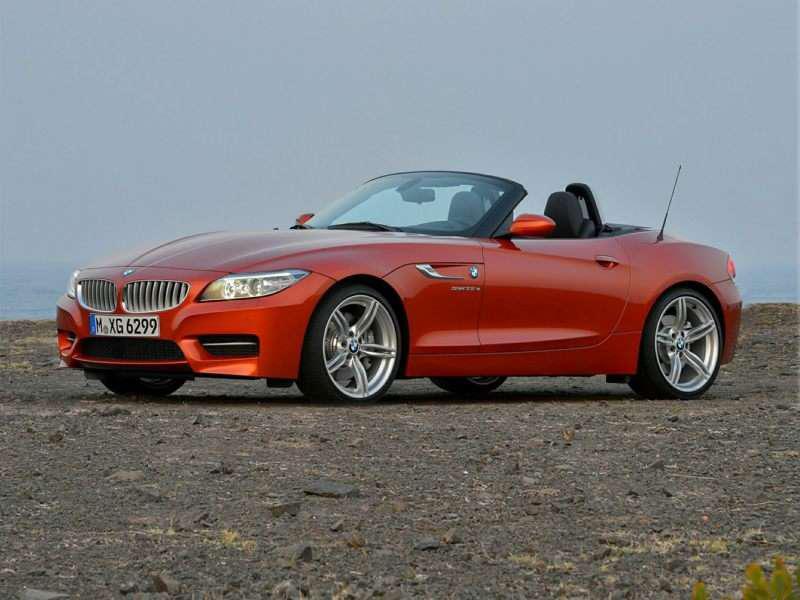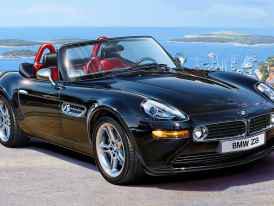The first image is the image on the left, the second image is the image on the right. For the images displayed, is the sentence "A body of water is in the background of a convertible in one of the images." factually correct? Answer yes or no. Yes. The first image is the image on the left, the second image is the image on the right. Evaluate the accuracy of this statement regarding the images: "One of the cars is red.". Is it true? Answer yes or no. Yes. 